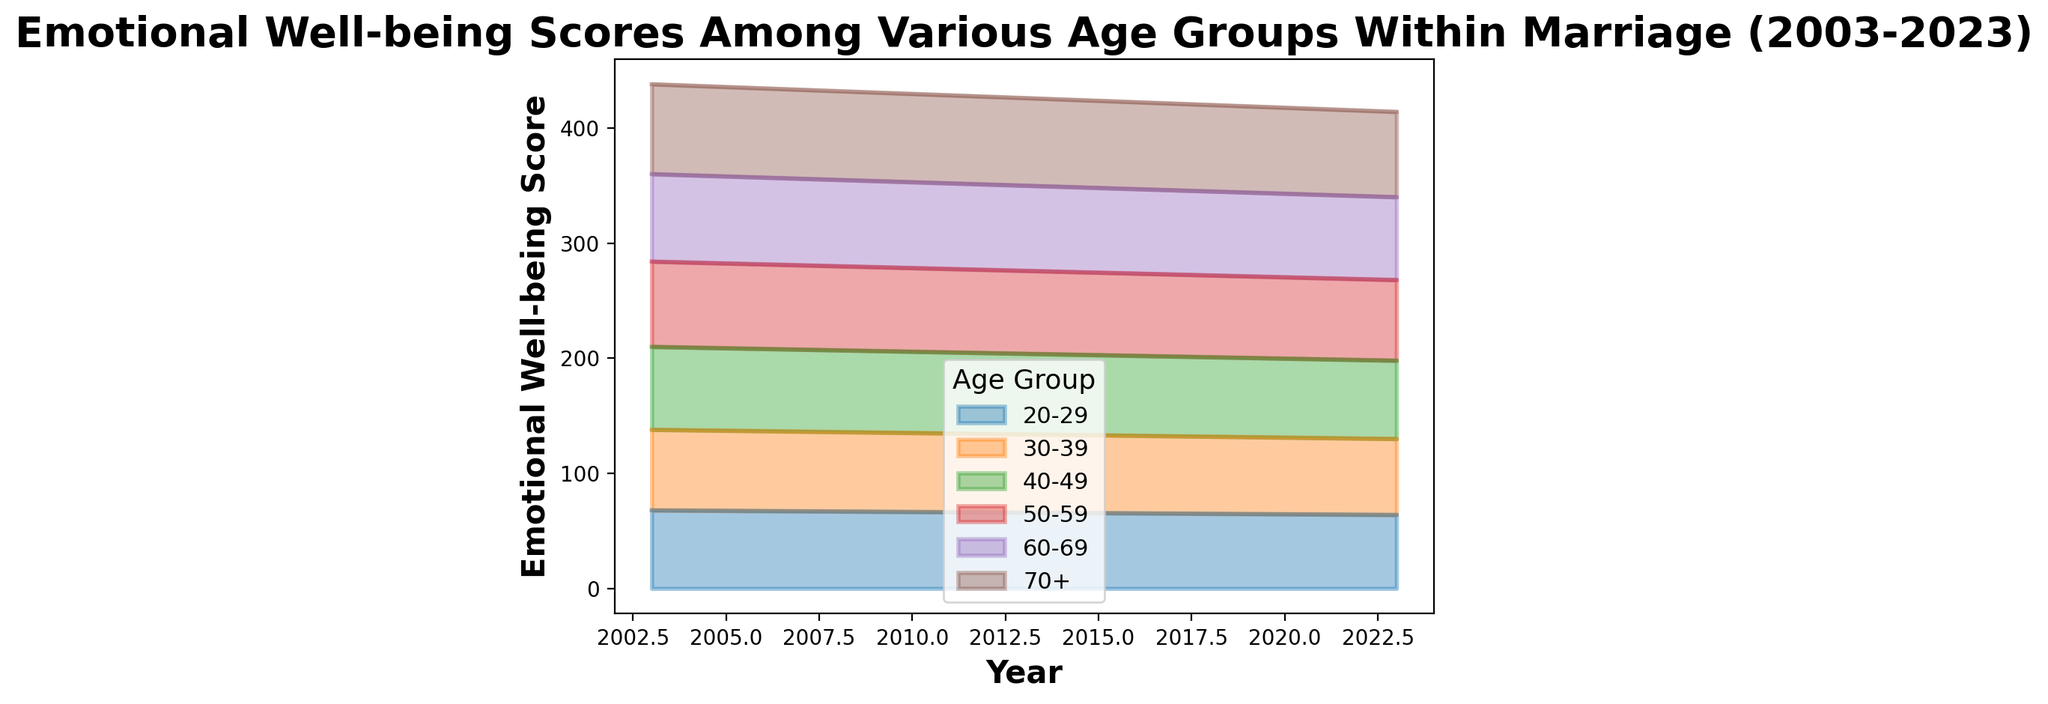What is the overall trend of emotional well-being scores across all age groups over the 20-year period? Looking at the area chart, all age groups show a gradual decrease in emotional well-being scores from 2003 to 2023.
Answer: Gradual decrease Which age group had the highest score in 2003, and what was the score? From the area chart, we can see that the 70+ age group had the highest emotional well-being score in 2003, which was 78.
Answer: 70+, 78 Compare the emotional well-being scores for the 20-29 age group and the 70+ age group in 2023. Which group had a higher score? The area chart indicates that in 2023, the 70+ age group had a higher emotional well-being score (74) compared to the 20-29 age group (64).
Answer: 70+ Which age group showed the most significant decrease in emotional well-being scores from 2003 to 2023? To identify this, we look at the slopes of the lines in the area chart. The 20-29 age group shows the largest decrease from 68 in 2003 to 64 in 2023, a 4-point decrease.
Answer: 20-29 By how many points did the emotional well-being score of the 50-59 age group change from 2003 to 2023? The area chart shows that in 2003, the score was 74 and it dropped to 70 in 2023. The change in points is 74 - 70 = 4.
Answer: 4 Considering the average emotional well-being score of the 30-39 age group over the 20 years depicted, what is the average score? To find the average, sum the scores of the 30-39 age group over the 5 time points and divide by 5. (70 + 69 + 68 + 67 + 66) / 5 = 68
Answer: 68 Compare the emotional well-being trends of the 40-49 age group to the 60-69 age group from 2003 to 2023. Which group had a more stable trend? By observing the area chart, the 60-69 age group demonstrates a more stable trend with a slight decrease from 76 to 72 (4 points), compared to the 40-49 age group which decreases from 72 to 68 (4 points but more variable).
Answer: 60-69 Which year had the highest aggregate emotional well-being score across all age groups, and what was that aggregate score? Sum the scores for each year and compare. In 2003: 68+70+72+74+76+78 = 438. Subsequent years’ sums are lower. Thus, 2003 had the highest aggregate score.
Answer: 2003, 438 